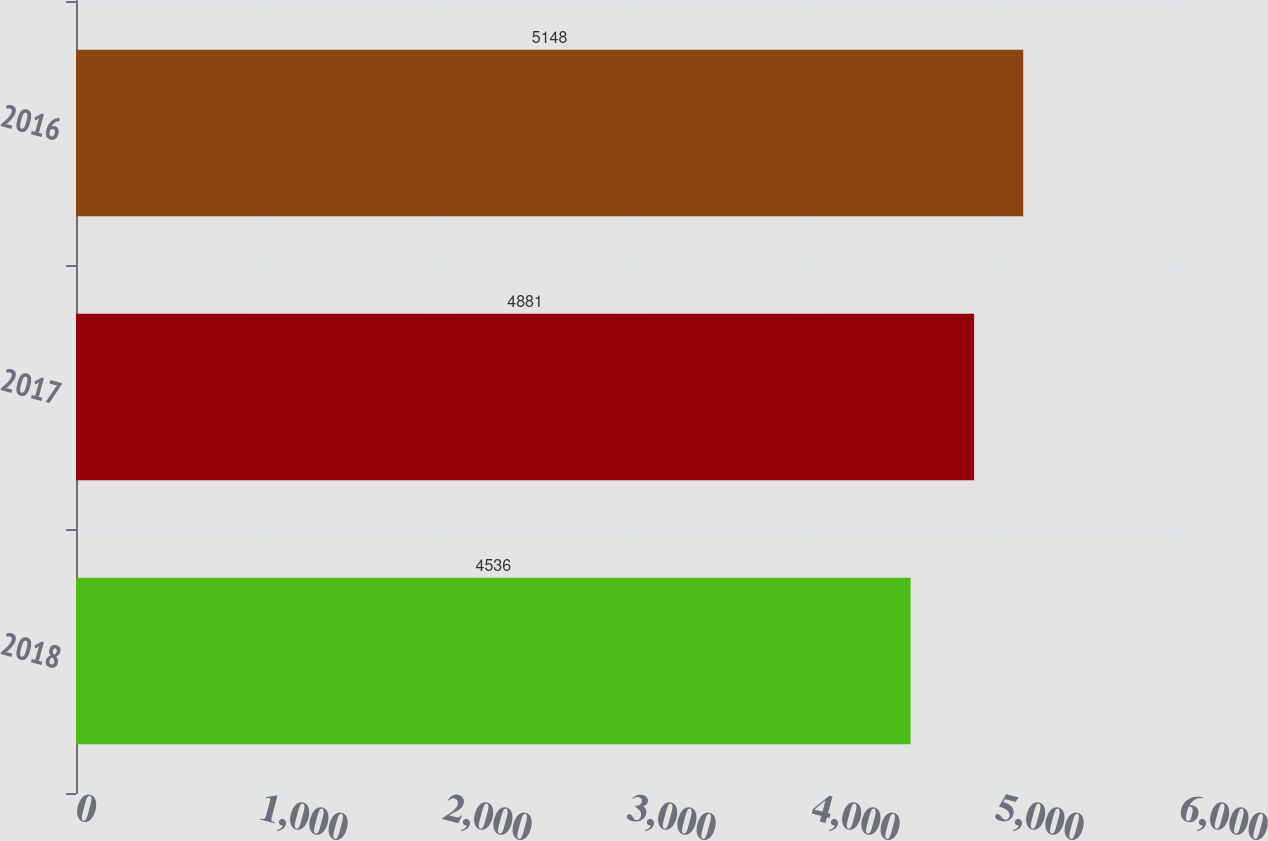Convert chart. <chart><loc_0><loc_0><loc_500><loc_500><bar_chart><fcel>2018<fcel>2017<fcel>2016<nl><fcel>4536<fcel>4881<fcel>5148<nl></chart> 